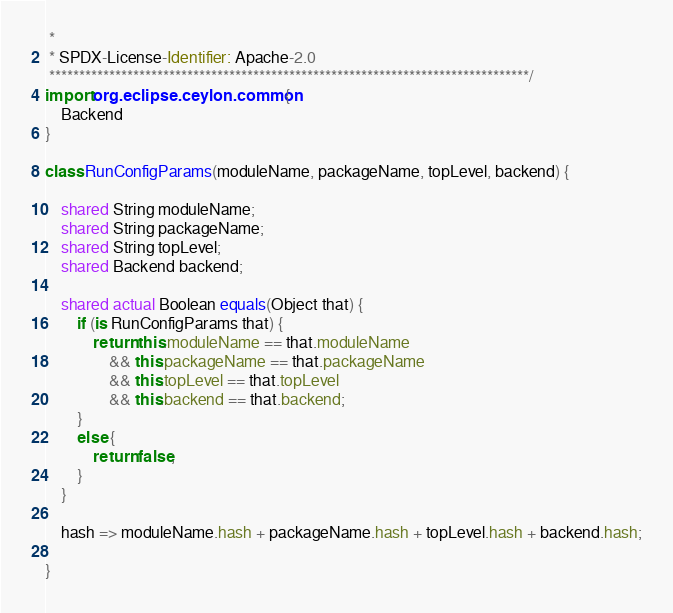Convert code to text. <code><loc_0><loc_0><loc_500><loc_500><_Ceylon_> *
 * SPDX-License-Identifier: Apache-2.0 
 ********************************************************************************/
import org.eclipse.ceylon.common {
    Backend
}

class RunConfigParams(moduleName, packageName, topLevel, backend) {

    shared String moduleName;
    shared String packageName;
    shared String topLevel;
    shared Backend backend;

    shared actual Boolean equals(Object that) {
        if (is RunConfigParams that) {
            return this.moduleName == that.moduleName
                && this.packageName == that.packageName
                && this.topLevel == that.topLevel
                && this.backend == that.backend;
        }
        else {
            return false;
        }
    }

    hash => moduleName.hash + packageName.hash + topLevel.hash + backend.hash;

}</code> 